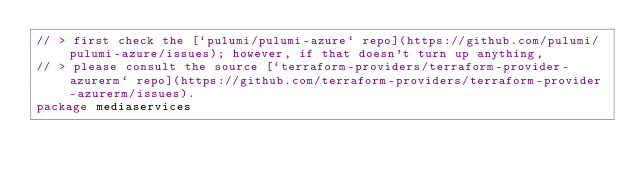Convert code to text. <code><loc_0><loc_0><loc_500><loc_500><_Go_>// > first check the [`pulumi/pulumi-azure` repo](https://github.com/pulumi/pulumi-azure/issues); however, if that doesn't turn up anything,
// > please consult the source [`terraform-providers/terraform-provider-azurerm` repo](https://github.com/terraform-providers/terraform-provider-azurerm/issues).
package mediaservices
</code> 